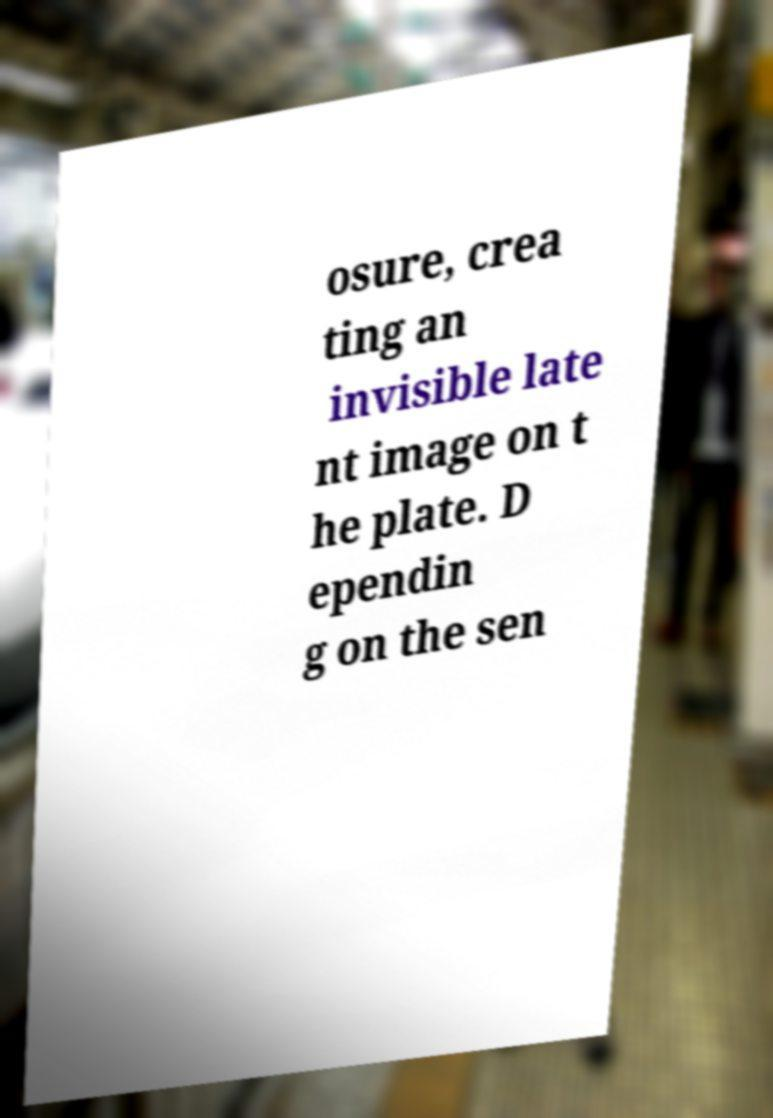Please identify and transcribe the text found in this image. osure, crea ting an invisible late nt image on t he plate. D ependin g on the sen 